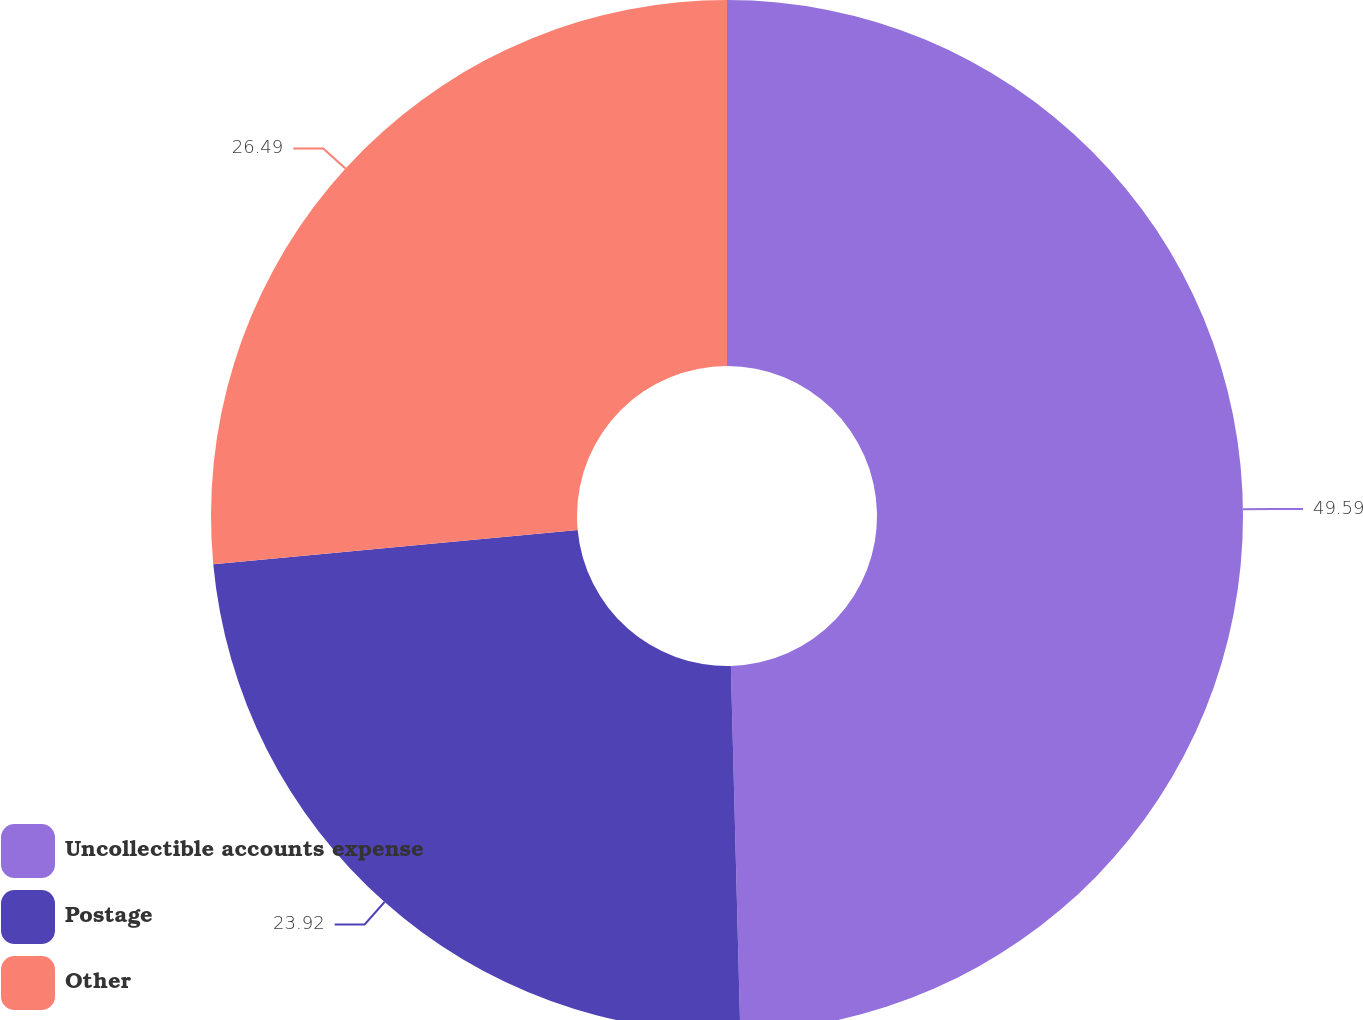<chart> <loc_0><loc_0><loc_500><loc_500><pie_chart><fcel>Uncollectible accounts expense<fcel>Postage<fcel>Other<nl><fcel>49.59%<fcel>23.92%<fcel>26.49%<nl></chart> 